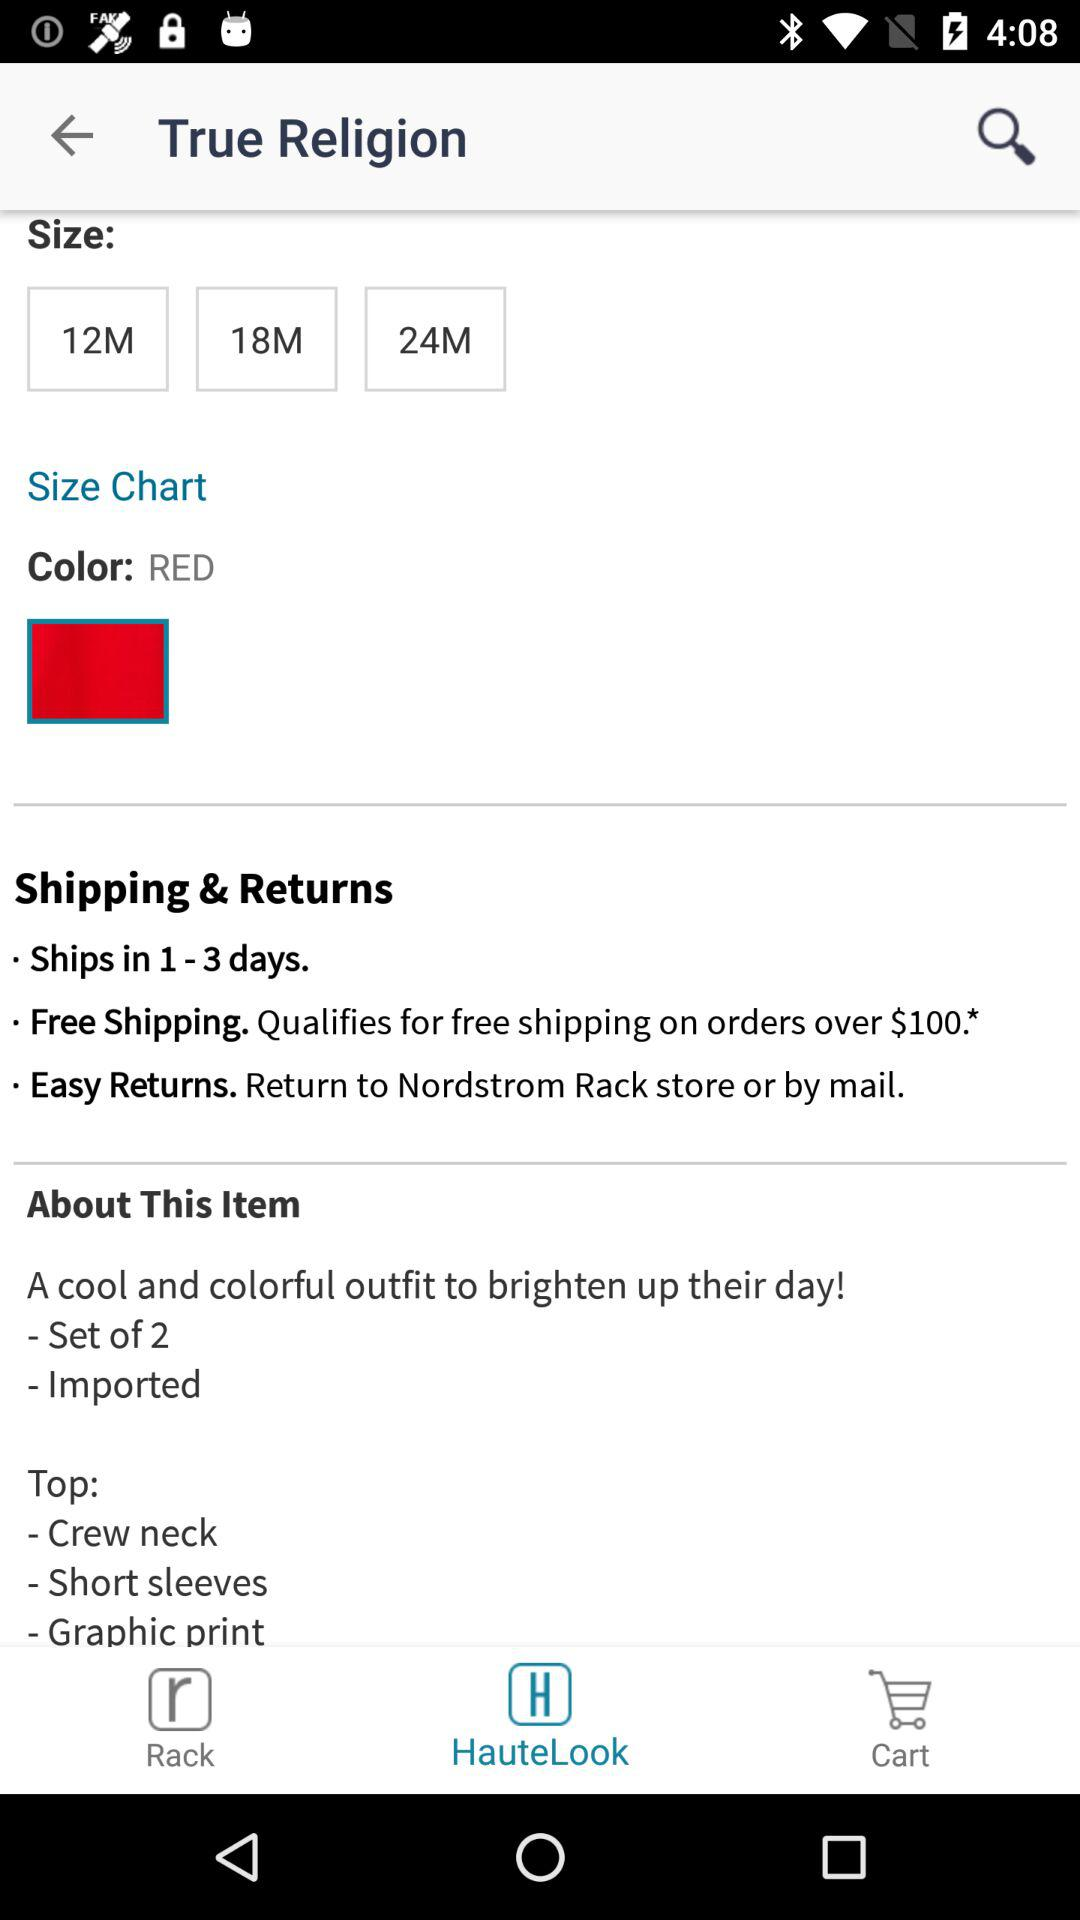What color is given? The given color is red. 